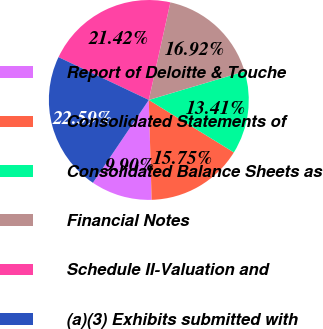<chart> <loc_0><loc_0><loc_500><loc_500><pie_chart><fcel>Report of Deloitte & Touche<fcel>Consolidated Statements of<fcel>Consolidated Balance Sheets as<fcel>Financial Notes<fcel>Schedule II-Valuation and<fcel>(a)(3) Exhibits submitted with<nl><fcel>9.9%<fcel>15.75%<fcel>13.41%<fcel>16.92%<fcel>21.42%<fcel>22.59%<nl></chart> 